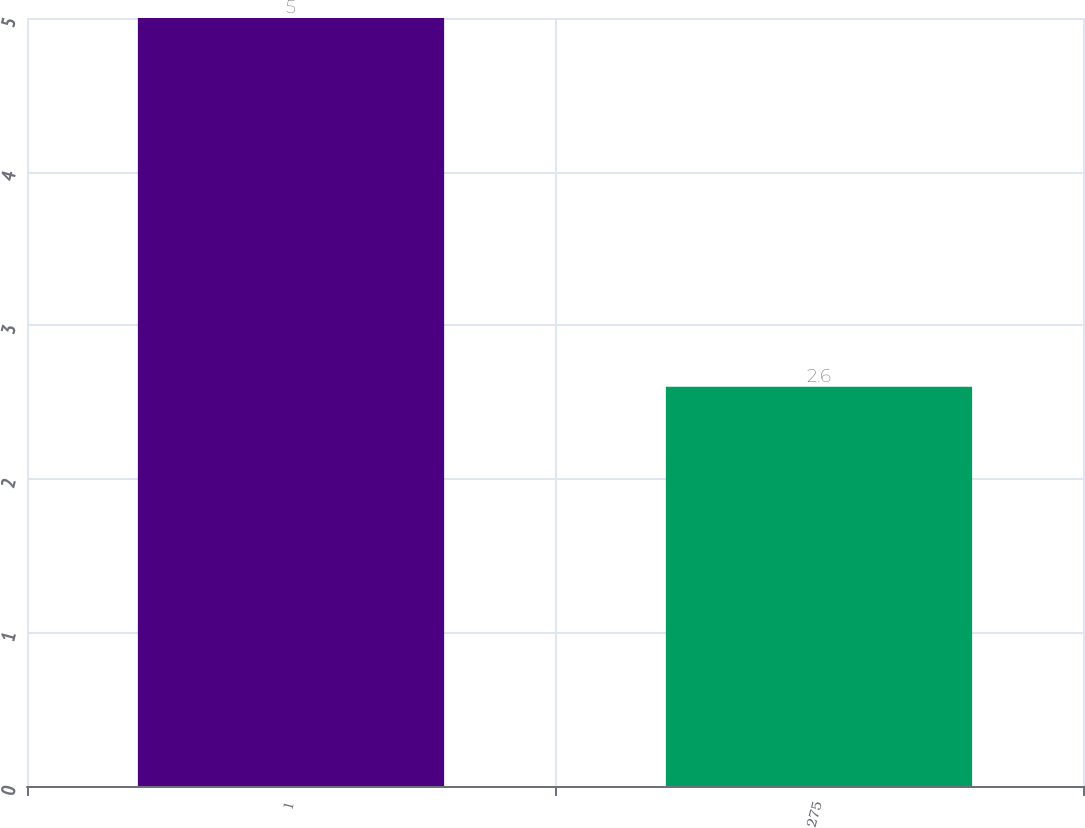Convert chart to OTSL. <chart><loc_0><loc_0><loc_500><loc_500><bar_chart><fcel>1<fcel>275<nl><fcel>5<fcel>2.6<nl></chart> 